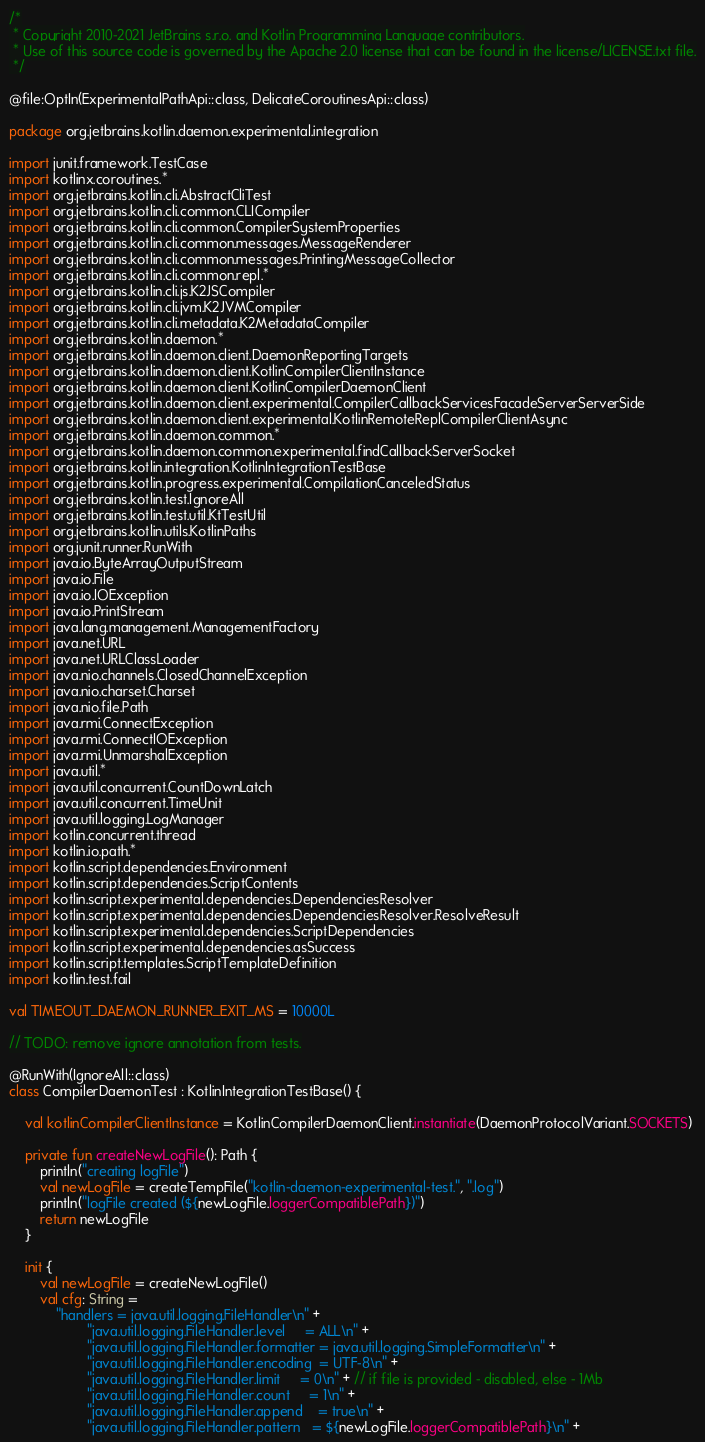Convert code to text. <code><loc_0><loc_0><loc_500><loc_500><_Kotlin_>/*
 * Copyright 2010-2021 JetBrains s.r.o. and Kotlin Programming Language contributors.
 * Use of this source code is governed by the Apache 2.0 license that can be found in the license/LICENSE.txt file.
 */

@file:OptIn(ExperimentalPathApi::class, DelicateCoroutinesApi::class)

package org.jetbrains.kotlin.daemon.experimental.integration

import junit.framework.TestCase
import kotlinx.coroutines.*
import org.jetbrains.kotlin.cli.AbstractCliTest
import org.jetbrains.kotlin.cli.common.CLICompiler
import org.jetbrains.kotlin.cli.common.CompilerSystemProperties
import org.jetbrains.kotlin.cli.common.messages.MessageRenderer
import org.jetbrains.kotlin.cli.common.messages.PrintingMessageCollector
import org.jetbrains.kotlin.cli.common.repl.*
import org.jetbrains.kotlin.cli.js.K2JSCompiler
import org.jetbrains.kotlin.cli.jvm.K2JVMCompiler
import org.jetbrains.kotlin.cli.metadata.K2MetadataCompiler
import org.jetbrains.kotlin.daemon.*
import org.jetbrains.kotlin.daemon.client.DaemonReportingTargets
import org.jetbrains.kotlin.daemon.client.KotlinCompilerClientInstance
import org.jetbrains.kotlin.daemon.client.KotlinCompilerDaemonClient
import org.jetbrains.kotlin.daemon.client.experimental.CompilerCallbackServicesFacadeServerServerSide
import org.jetbrains.kotlin.daemon.client.experimental.KotlinRemoteReplCompilerClientAsync
import org.jetbrains.kotlin.daemon.common.*
import org.jetbrains.kotlin.daemon.common.experimental.findCallbackServerSocket
import org.jetbrains.kotlin.integration.KotlinIntegrationTestBase
import org.jetbrains.kotlin.progress.experimental.CompilationCanceledStatus
import org.jetbrains.kotlin.test.IgnoreAll
import org.jetbrains.kotlin.test.util.KtTestUtil
import org.jetbrains.kotlin.utils.KotlinPaths
import org.junit.runner.RunWith
import java.io.ByteArrayOutputStream
import java.io.File
import java.io.IOException
import java.io.PrintStream
import java.lang.management.ManagementFactory
import java.net.URL
import java.net.URLClassLoader
import java.nio.channels.ClosedChannelException
import java.nio.charset.Charset
import java.nio.file.Path
import java.rmi.ConnectException
import java.rmi.ConnectIOException
import java.rmi.UnmarshalException
import java.util.*
import java.util.concurrent.CountDownLatch
import java.util.concurrent.TimeUnit
import java.util.logging.LogManager
import kotlin.concurrent.thread
import kotlin.io.path.*
import kotlin.script.dependencies.Environment
import kotlin.script.dependencies.ScriptContents
import kotlin.script.experimental.dependencies.DependenciesResolver
import kotlin.script.experimental.dependencies.DependenciesResolver.ResolveResult
import kotlin.script.experimental.dependencies.ScriptDependencies
import kotlin.script.experimental.dependencies.asSuccess
import kotlin.script.templates.ScriptTemplateDefinition
import kotlin.test.fail

val TIMEOUT_DAEMON_RUNNER_EXIT_MS = 10000L

// TODO: remove ignore annotation from tests.

@RunWith(IgnoreAll::class)
class CompilerDaemonTest : KotlinIntegrationTestBase() {

    val kotlinCompilerClientInstance = KotlinCompilerDaemonClient.instantiate(DaemonProtocolVariant.SOCKETS)

    private fun createNewLogFile(): Path {
        println("creating logFile")
        val newLogFile = createTempFile("kotlin-daemon-experimental-test.", ".log")
        println("logFile created (${newLogFile.loggerCompatiblePath})")
        return newLogFile
    }

    init {
        val newLogFile = createNewLogFile()
        val cfg: String =
            "handlers = java.util.logging.FileHandler\n" +
                    "java.util.logging.FileHandler.level     = ALL\n" +
                    "java.util.logging.FileHandler.formatter = java.util.logging.SimpleFormatter\n" +
                    "java.util.logging.FileHandler.encoding  = UTF-8\n" +
                    "java.util.logging.FileHandler.limit     = 0\n" + // if file is provided - disabled, else - 1Mb
                    "java.util.logging.FileHandler.count     = 1\n" +
                    "java.util.logging.FileHandler.append    = true\n" +
                    "java.util.logging.FileHandler.pattern   = ${newLogFile.loggerCompatiblePath}\n" +</code> 